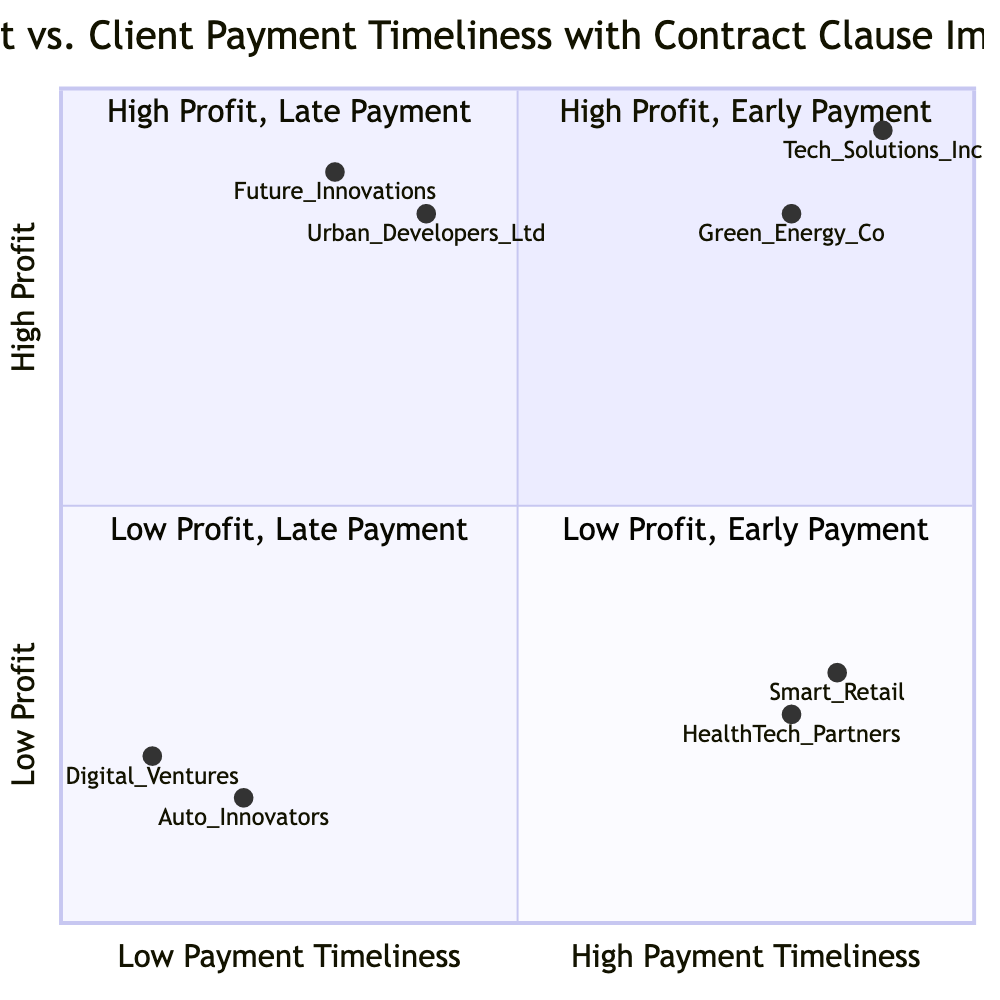What clients are in the "High Profit, Early Payment" quadrant? The "High Profit, Early Payment" quadrant contains two clients: Tech Solutions Inc. and Green Energy Co. These clients are characterized by high profit and timely or early payments.
Answer: Tech Solutions Inc. and Green Energy Co What is the payment timeliness of Future Innovations? Future Innovations is located in the "High Profit, Late Payment" quadrant, indicating its payment timeliness is 15 days late.
Answer: 15 days late Which client has the lowest profit in the "Low Profit, Late Payment" quadrant? The "Low Profit, Late Payment" quadrant includes Auto Innovators and Digital Ventures. Auto Innovators has a profit of $30,000, which is lower than Digital Ventures' $40,000.
Answer: Auto Innovators How many clients are shown in the "Low Profit, Early Payment" quadrant? The "Low Profit, Early Payment" quadrant consists of two clients: Smart Retail and HealthTech Partners. Therefore, the total number of clients in this quadrant is two.
Answer: 2 Which quadrant contains clients with both high profit and high impact of contract clauses? The "High Profit, Early Payment" quadrant contains clients that achieve both high profits and have a significant impact from contract clauses on their payment timelines. The presence of Tech Solutions Inc. supports this observation.
Answer: High Profit, Early Payment What is the impact of contract clauses on the payment timeliness for Auto Innovators? Auto Innovators falls into the "Low Profit, Late Payment" quadrant, where the impact of contract clauses is listed as low, highlighting that contract provisions did not significantly improve payment timeliness.
Answer: Low How does the profit of Green Energy Co. compare to that of Urban Developers Ltd.? Green Energy Co., located in the "High Profit, Early Payment" quadrant, shows a profit of $150,000. In contrast, Urban Developers Ltd., positioned in the "High Profit, Late Payment" quadrant, has a profit of $170,000, indicating that Urban Developers Ltd. has higher profit than Green Energy Co.
Answer: Urban Developers Ltd. has higher profit What is the payment timeliness for clients in the "Low Profit, Early Payment" quadrant? Both clients in the "Low Profit, Early Payment" quadrant, Smart Retail and HealthTech Partners, have payment timelines of either early or on time. Smart Retail is 5 days early, and HealthTech Partners is on time, which denotes that prompt payment is a characteristic of this quadrant.
Answer: 5 days early and on time 